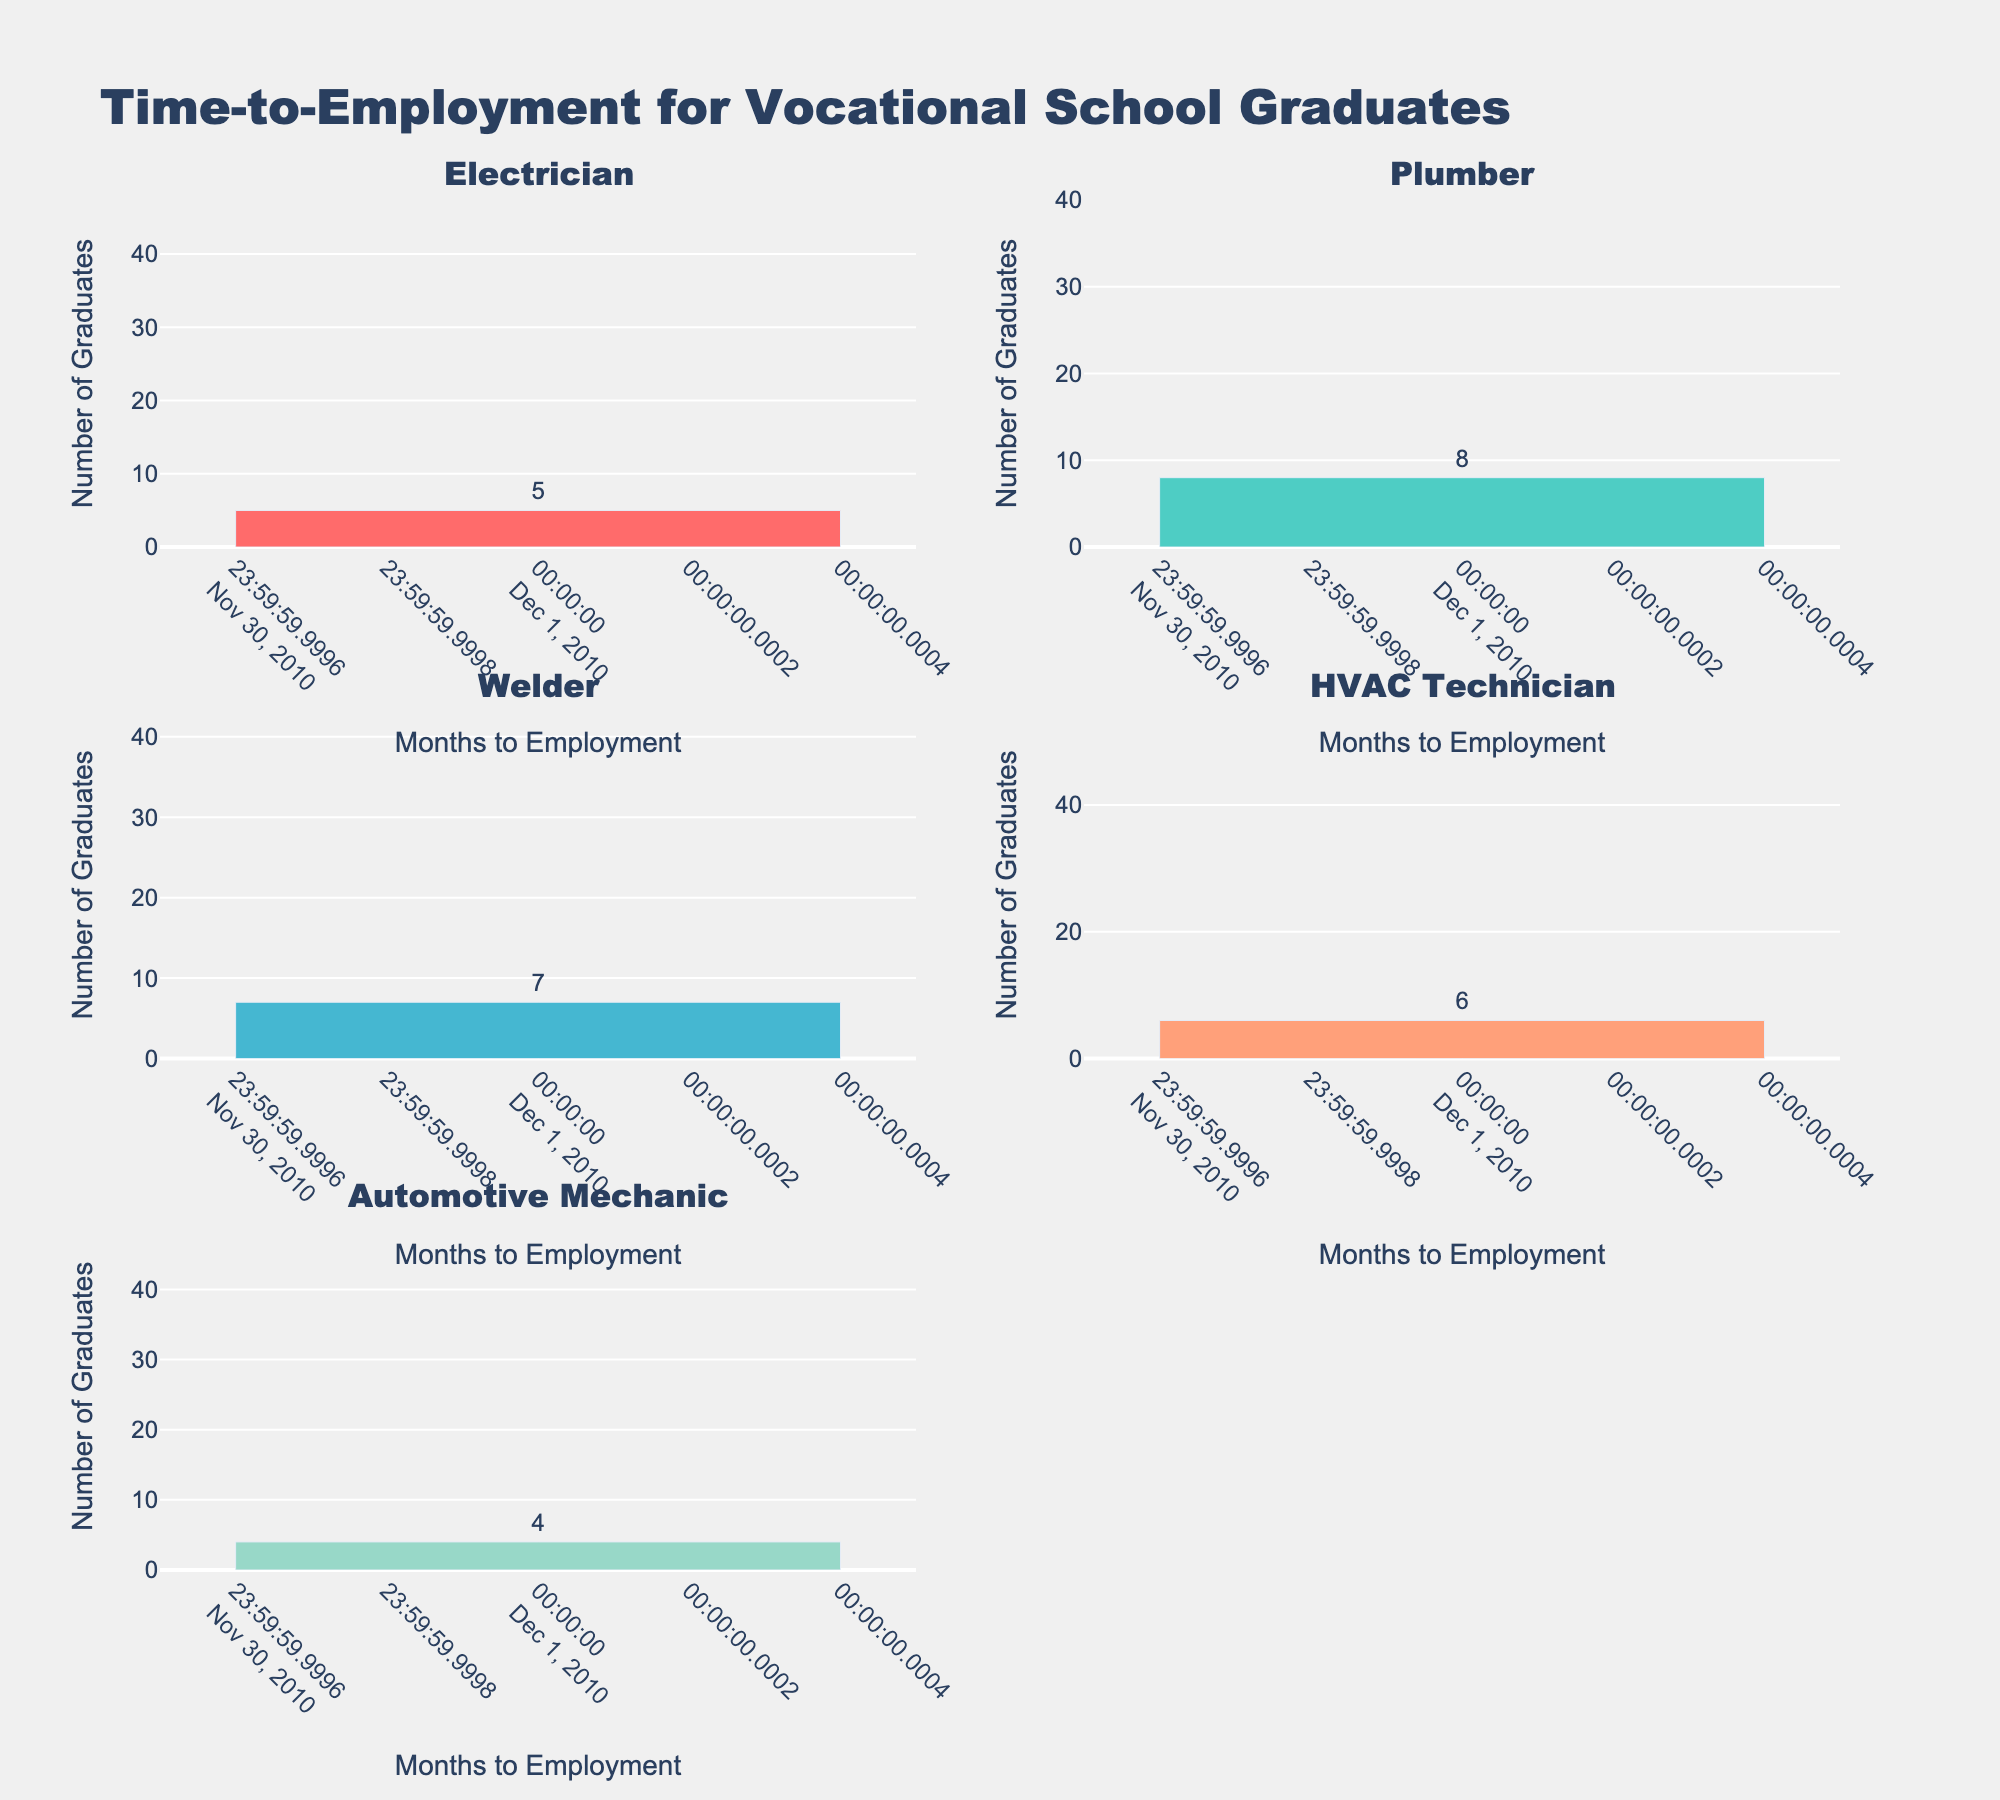What is the highest number of graduates employed within 0-3 months for any trade? Look at the bar heights under 0-3 months for each trade. The highest bar corresponds to HVAC Technicians with 52 graduates.
Answer: 52 Which trade has the least number of graduates finding employment within 10-12 months? Compare the bar heights for 10-12 months across all trades. Electricians have the smallest bar with 5 graduates.
Answer: Electricians Which trade has more graduates employed within 4-6 months, Plumbers or Welders? Compare the bar heights for 4-6 months between Plumbers and Welders. Plumbers have 29 graduates and Welders have 35 graduates.
Answer: Welders How many total graduates found employment within 0-3 months across all trades? Sum the number of graduates in the 0-3 months category for all trades: 45 (Electricians) + 38 (Plumbers) + 41 (Welders) + 52 (HVAC Technicians) + 47 (Automotive Mechanics) = 223 graduates.
Answer: 223 What is the average number of graduates employed within 7-9 months across all trades? Calculate the total number of graduates in the 7-9 months category: 18 (Electricians) + 15 (Plumbers) + 12 (Welders) + 14 (HVAC Technicians) + 16 (Automotive Mechanics) = 75 graduates. Divide by the number of trades: 75 / 5 = 15 graduates.
Answer: 15 Which trade has the steadiest decline in employment numbers over the 12-month period? Observe the employment trend for each trade. Electricians show a consistent decline: 45 (0-3 months), 32 (4-6 months), 18 (7-9 months), 5 (10-12 months).
Answer: Electricians How many total graduates from the HVAC Technician trade found employment within 6 months? Add the number of graduates in the 0-3 months and 4-6 months categories for HVAC Technicians: 52 (0-3 months) + 28 (4-6 months) = 80 graduates.
Answer: 80 Which trade has the highest number of graduates finding employment within 4-6 months? Compare the bar heights for 4-6 months across all trades. Automotive Mechanics have the highest number with 33 graduates.
Answer: Automotive Mechanics What is the combined number of graduates from the Welder trade employed within 7-12 months? Add the number of graduates in the 7-9 months and 10-12 months categories for Welders: 12 (7-9 months) + 7 (10-12 months) = 19 graduates.
Answer: 19 Which trade shows the largest initial drop in the number of graduates employed between 0-3 months and 4-6 months? Subtract the number of graduates employed within 4-6 months from those employed within 0-3 months for each trade. HVAC Technicians have the largest drop: 52 - 28 = 24 graduates.
Answer: HVAC Technicians 